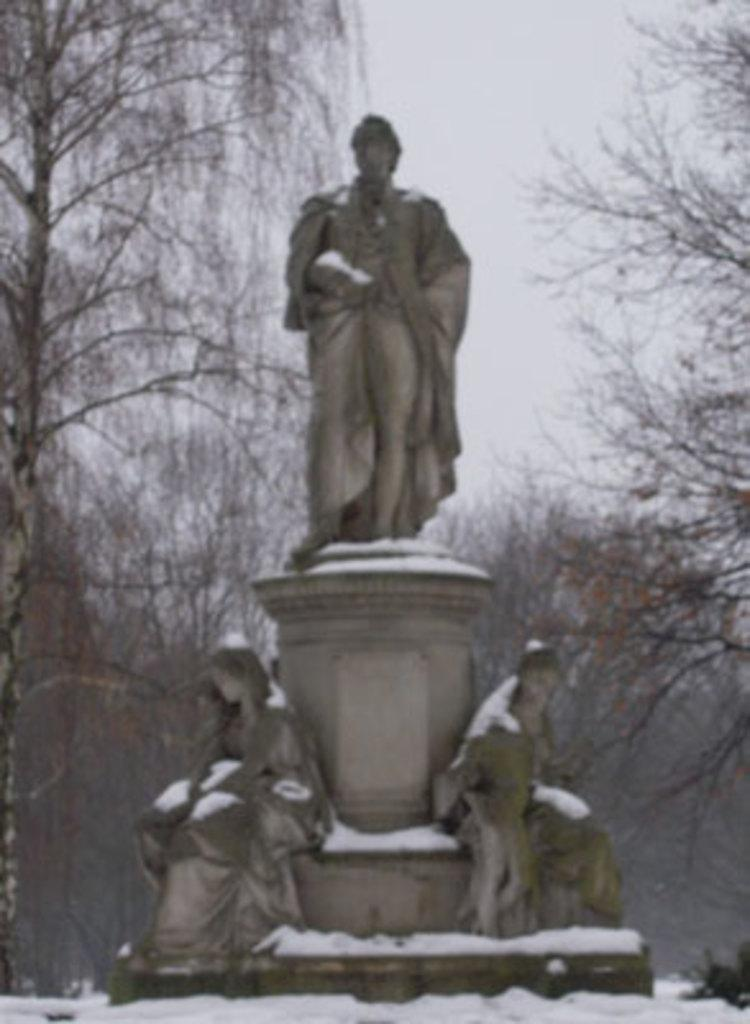What is the color scheme of the image? The image is black and white. What is the main subject in the center of the image? There is a sculpture in the center of the image. What type of weather is depicted at the bottom of the image? There is snow at the bottom of the image. What can be seen in the background of the image? There are trees in the background of the image. What industry is being reported on in the news in the image? There is no news or reference to any industry in the image; it features a black and white sculpture with snow and trees in the background. 